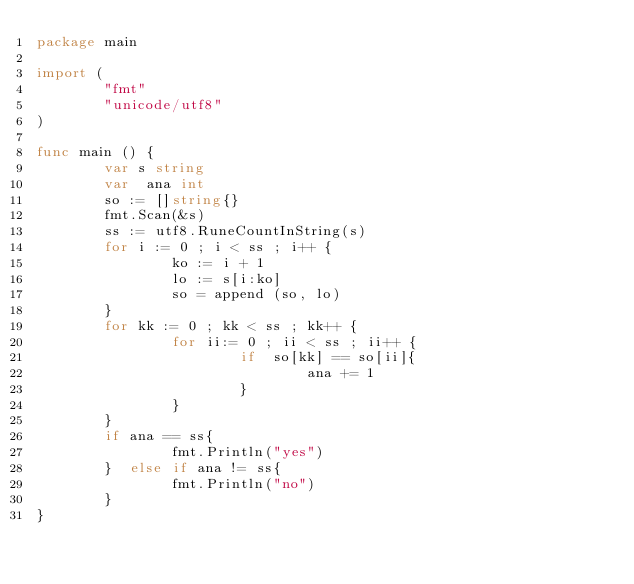Convert code to text. <code><loc_0><loc_0><loc_500><loc_500><_Go_>package main 

import (
        "fmt"
        "unicode/utf8"
)

func main () {
        var s string
        var  ana int
        so := []string{}
        fmt.Scan(&s)
        ss := utf8.RuneCountInString(s)
        for i := 0 ; i < ss ; i++ {
                ko := i + 1
                lo := s[i:ko]
                so = append (so, lo)
        }
        for kk := 0 ; kk < ss ; kk++ {
                for ii:= 0 ; ii < ss ; ii++ {
                        if  so[kk] == so[ii]{
                                ana += 1
                        }
                }
        }
        if ana == ss{
                fmt.Println("yes")
        }  else if ana != ss{
                fmt.Println("no")
        }
}
</code> 